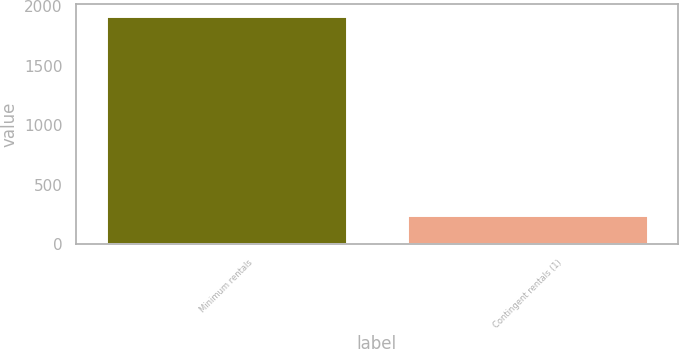<chart> <loc_0><loc_0><loc_500><loc_500><bar_chart><fcel>Minimum rentals<fcel>Contingent rentals (1)<nl><fcel>1919<fcel>245<nl></chart> 